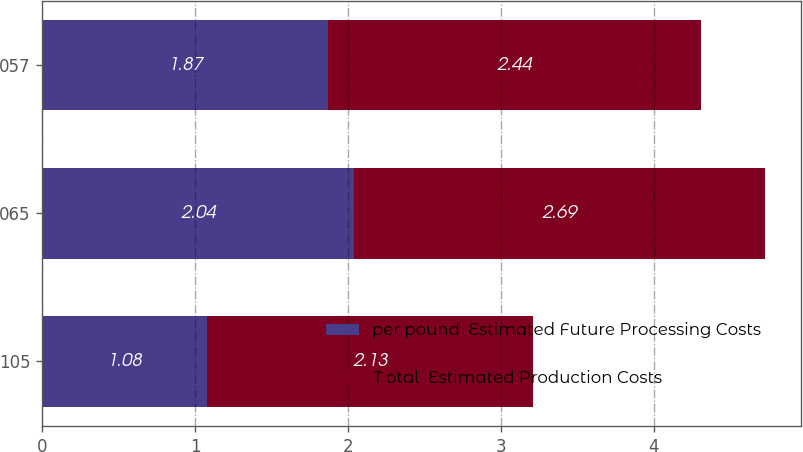Convert chart to OTSL. <chart><loc_0><loc_0><loc_500><loc_500><stacked_bar_chart><ecel><fcel>105<fcel>065<fcel>057<nl><fcel>per pound  Estimated Future Processing Costs<fcel>1.08<fcel>2.04<fcel>1.87<nl><fcel>T otal  Estimated Production Costs<fcel>2.13<fcel>2.69<fcel>2.44<nl></chart> 